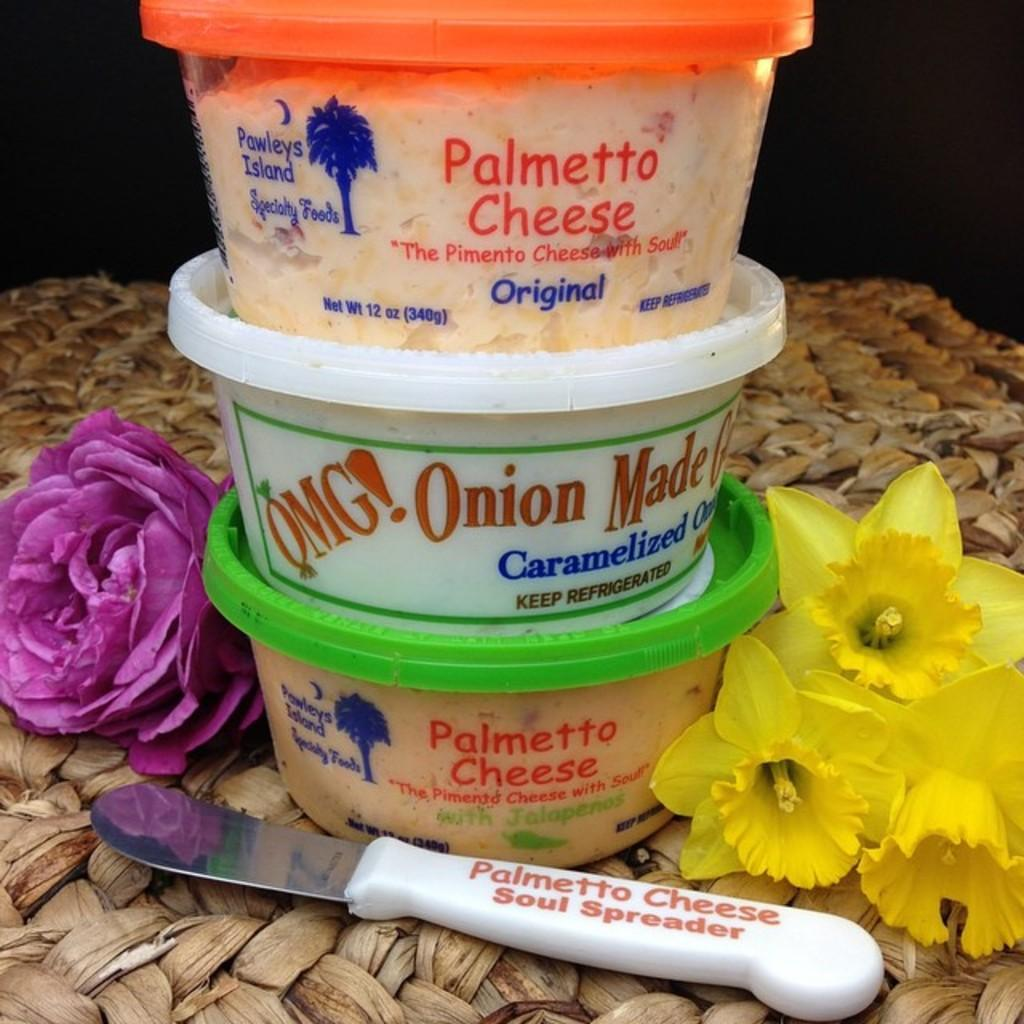<image>
Write a terse but informative summary of the picture. Stacked containers of Palmetto cheese and caramelized onions. 